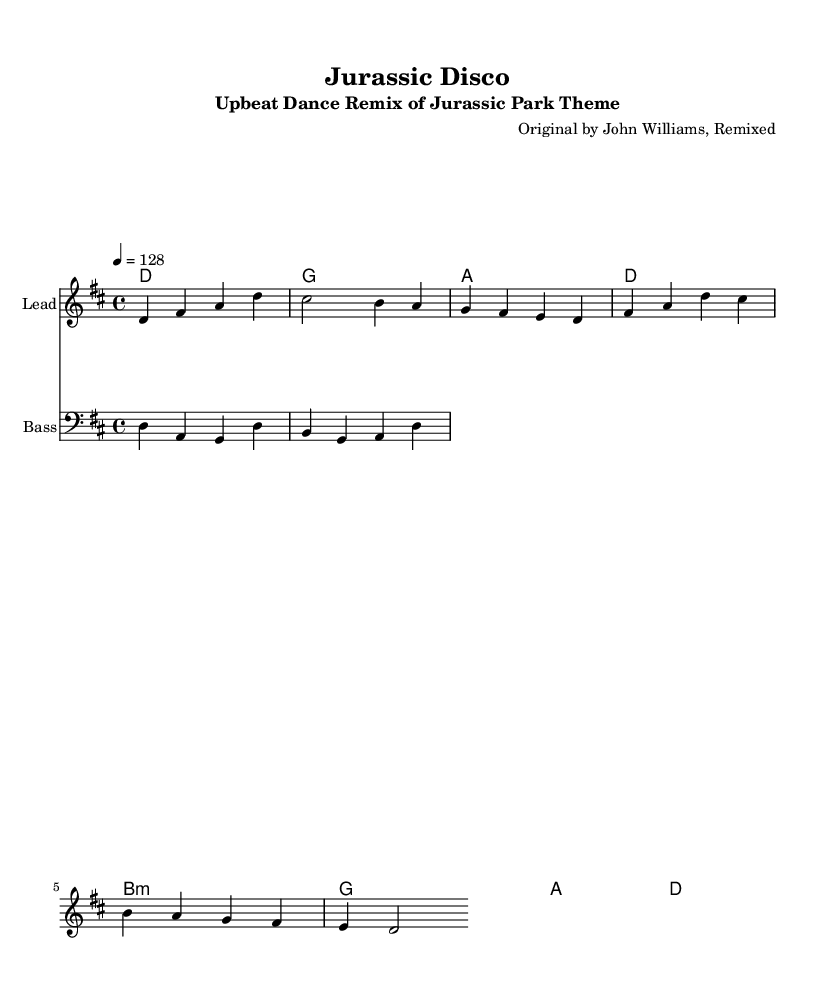What is the key signature of this music? The key signature is D major, indicated by two sharps (F# and C#) at the beginning of the staff.
Answer: D major What is the time signature of the piece? The time signature is 4/4, noted by the "4/4" written at the beginning of the score.
Answer: 4/4 What is the tempo marking for this remix? The score indicates a tempo of 128 beats per minute, specified by the "4 = 128" marking near the beginning.
Answer: 128 What is the name of the original composer? The composer is John Williams, recognized in the header section of the sheet music.
Answer: John Williams How many measures are in the melody section? The melody section contains four measures, counted from the notation provided in the score.
Answer: Four Which instrument is labeled "Lead"? The instrument labeled "Lead" is indicated in the staff name in the score, which specifies the melody part.
Answer: Lead What type of chord is the first chord of the harmony? The first chord listed is a D major chord, as reflected in the chord mode section of the score.
Answer: D major 